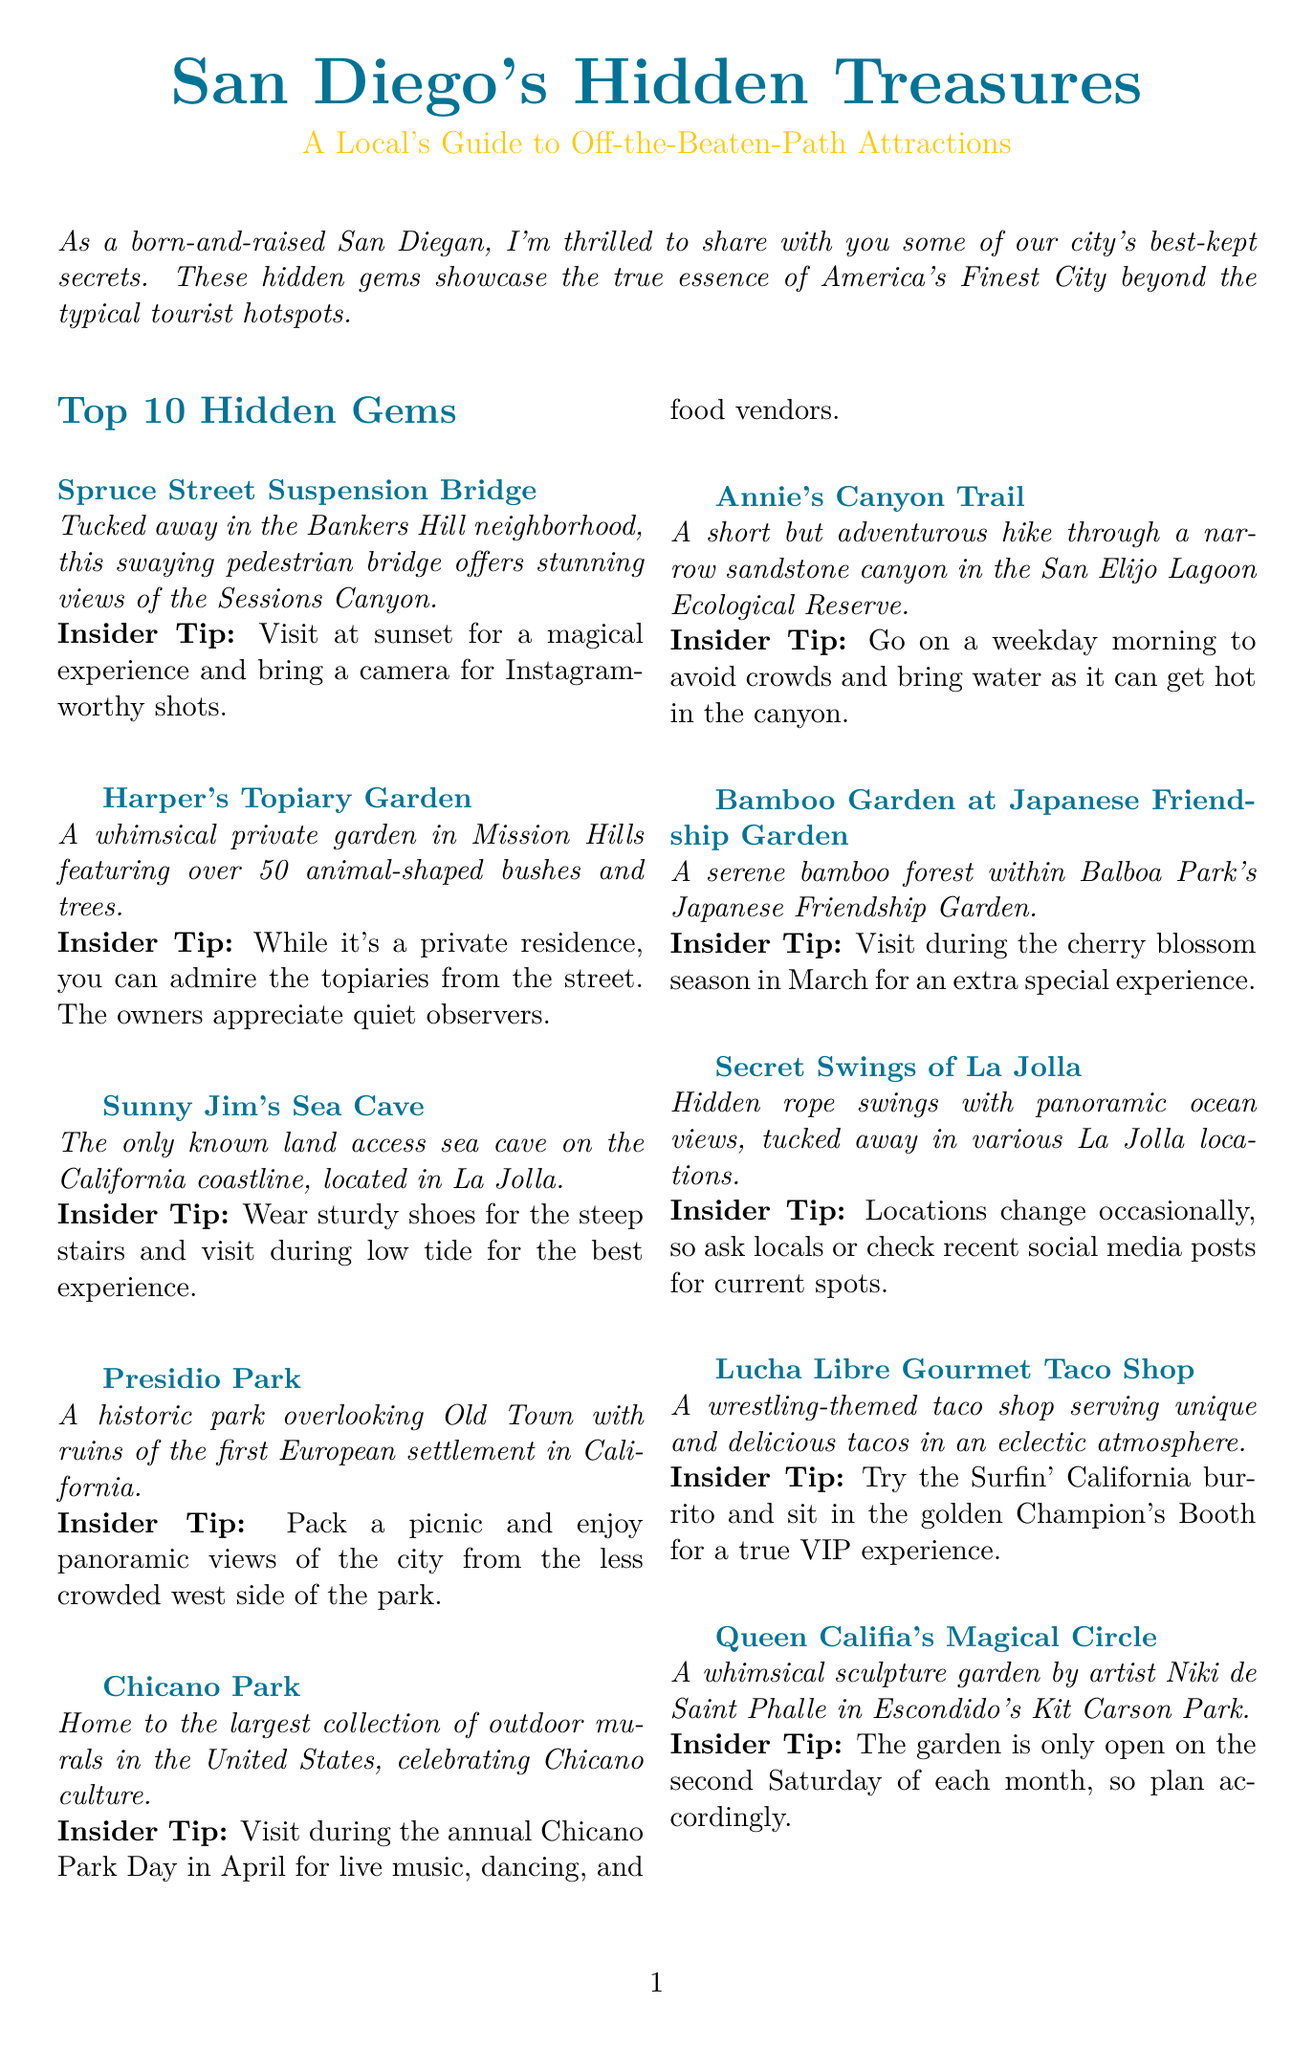What is the title of the newsletter? The title is clearly stated at the beginning of the document.
Answer: San Diego's Hidden Treasures: A Local's Guide to Off-the-Beaten-Path Attractions How many hidden gems are listed in the newsletter? The document explicitly mentions a section titled "Top 10 Hidden Gems."
Answer: 10 What is the insider tip for visiting Spruce Street Suspension Bridge? Each hidden gem includes a specific insider tip that enhances the visitor experience.
Answer: Visit at sunset for a magical experience and bring a camera for Instagram-worthy shots What is unique about Sunny Jim's Sea Cave? The description points out a distinctive feature that makes this location special.
Answer: The only known land access sea cave on the California coastline When is Queen Califia's Magical Circle open to the public? The insider tip for this gem specifies the only days when it can be visited.
Answer: The second Saturday of each month What should visitors bring when hiking Annie's Canyon Trail? The insider tip suggests an essential item for this hike due to conditions mentioned in the document.
Answer: Water What type of cuisine does Lucha Libre Gourmet Taco Shop serve? The document describes the theme and offerings of this food location.
Answer: Tacos What event is suggested to visit during at Chicano Park? The document highlights a specific event that provides a special experience at this park.
Answer: Chicano Park Day 